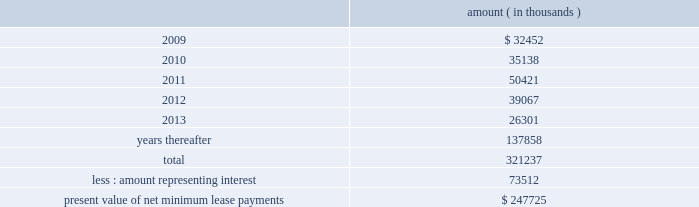Entergy corporation and subsidiaries notes to financial statements computed on a rolling 12 month basis .
As of december 31 , 2008 , entergy louisiana was in compliance with these provisions .
As of december 31 , 2008 , entergy louisiana had future minimum lease payments ( reflecting an overall implicit rate of 7.45% ( 7.45 % ) ) in connection with the waterford 3 sale and leaseback transactions , which are recorded as long-term debt , as follows : amount ( in thousands ) .
Grand gulf lease obligations in december 1988 , in two separate but substantially identical transactions , system energy sold and leased back undivided ownership interests in grand gulf for the aggregate sum of $ 500 million .
The interests represent approximately 11.5% ( 11.5 % ) of grand gulf .
The leases expire in 2015 .
Under certain circumstances , system entergy may repurchase the leased interests prior to the end of the term of the leases .
At the end of the lease terms , system energy has the option to repurchase the leased interests in grand gulf at fair market value or to renew the leases for either fair market value or , under certain conditions , a fixed rate .
In may 2004 , system energy caused the grand gulf lessors to refinance the outstanding bonds that they had issued to finance the purchase of their undivided interest in grand gulf .
The refinancing is at a lower interest rate , and system energy's lease payments have been reduced to reflect the lower interest costs .
System energy is required to report the sale-leaseback as a financing transaction in its financial statements .
For financial reporting purposes , system energy expenses the interest portion of the lease obligation and the plant depreciation .
However , operating revenues include the recovery of the lease payments because the transactions are accounted for as a sale and leaseback for ratemaking purposes .
Consistent with a recommendation contained in a ferc audit report , system energy initially recorded as a net regulatory asset the difference between the recovery of the lease payments and the amounts expensed for interest and depreciation and continues to record this difference as a regulatory asset or liability on an ongoing basis , resulting in a zero net balance for the regulatory asset at the end of the lease term .
The amount of this net regulatory asset was $ 19.2 million and $ 36.6 million as of december 31 , 2008 and 2007 , respectively. .
What percent of total lease payments is in 'years thereafter'? 
Computations: (137858 / 321237)
Answer: 0.42915. 